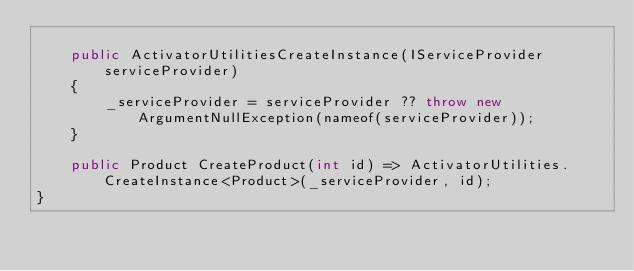Convert code to text. <code><loc_0><loc_0><loc_500><loc_500><_C#_>
    public ActivatorUtilitiesCreateInstance(IServiceProvider serviceProvider)
    {
        _serviceProvider = serviceProvider ?? throw new ArgumentNullException(nameof(serviceProvider));
    }

    public Product CreateProduct(int id) => ActivatorUtilities.CreateInstance<Product>(_serviceProvider, id);
}
</code> 